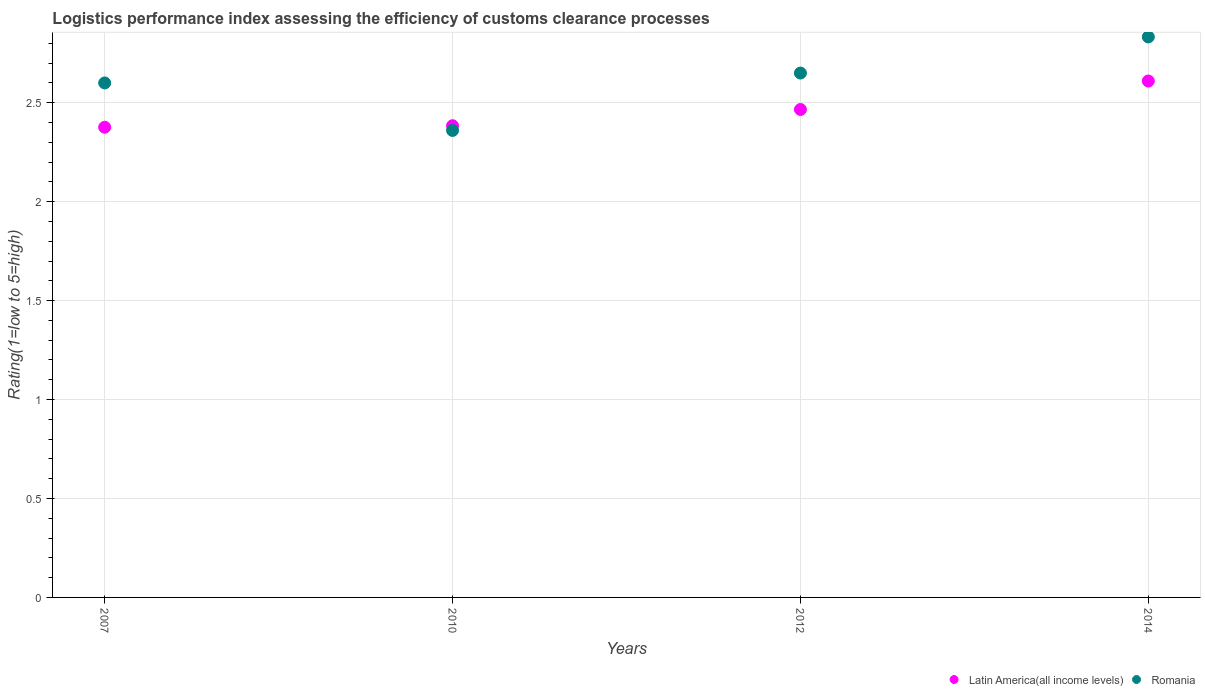How many different coloured dotlines are there?
Provide a succinct answer. 2. Is the number of dotlines equal to the number of legend labels?
Provide a succinct answer. Yes. What is the Logistic performance index in Latin America(all income levels) in 2010?
Offer a very short reply. 2.38. Across all years, what is the maximum Logistic performance index in Romania?
Make the answer very short. 2.83. Across all years, what is the minimum Logistic performance index in Romania?
Ensure brevity in your answer.  2.36. In which year was the Logistic performance index in Romania minimum?
Your answer should be compact. 2010. What is the total Logistic performance index in Latin America(all income levels) in the graph?
Make the answer very short. 9.84. What is the difference between the Logistic performance index in Romania in 2007 and that in 2010?
Keep it short and to the point. 0.24. What is the difference between the Logistic performance index in Romania in 2012 and the Logistic performance index in Latin America(all income levels) in 2010?
Make the answer very short. 0.27. What is the average Logistic performance index in Latin America(all income levels) per year?
Provide a short and direct response. 2.46. In the year 2014, what is the difference between the Logistic performance index in Latin America(all income levels) and Logistic performance index in Romania?
Provide a short and direct response. -0.22. In how many years, is the Logistic performance index in Latin America(all income levels) greater than 0.30000000000000004?
Offer a terse response. 4. What is the ratio of the Logistic performance index in Latin America(all income levels) in 2007 to that in 2010?
Make the answer very short. 1. Is the difference between the Logistic performance index in Latin America(all income levels) in 2007 and 2014 greater than the difference between the Logistic performance index in Romania in 2007 and 2014?
Offer a terse response. No. What is the difference between the highest and the second highest Logistic performance index in Romania?
Your answer should be very brief. 0.18. What is the difference between the highest and the lowest Logistic performance index in Romania?
Ensure brevity in your answer.  0.47. Is the sum of the Logistic performance index in Romania in 2010 and 2014 greater than the maximum Logistic performance index in Latin America(all income levels) across all years?
Keep it short and to the point. Yes. Does the Logistic performance index in Latin America(all income levels) monotonically increase over the years?
Your answer should be compact. Yes. Is the Logistic performance index in Latin America(all income levels) strictly greater than the Logistic performance index in Romania over the years?
Your response must be concise. No. Is the Logistic performance index in Latin America(all income levels) strictly less than the Logistic performance index in Romania over the years?
Give a very brief answer. No. How many dotlines are there?
Provide a short and direct response. 2. How many years are there in the graph?
Keep it short and to the point. 4. Does the graph contain any zero values?
Ensure brevity in your answer.  No. Does the graph contain grids?
Ensure brevity in your answer.  Yes. Where does the legend appear in the graph?
Ensure brevity in your answer.  Bottom right. What is the title of the graph?
Give a very brief answer. Logistics performance index assessing the efficiency of customs clearance processes. What is the label or title of the X-axis?
Your response must be concise. Years. What is the label or title of the Y-axis?
Your answer should be compact. Rating(1=low to 5=high). What is the Rating(1=low to 5=high) in Latin America(all income levels) in 2007?
Offer a terse response. 2.38. What is the Rating(1=low to 5=high) of Romania in 2007?
Your response must be concise. 2.6. What is the Rating(1=low to 5=high) in Latin America(all income levels) in 2010?
Your answer should be compact. 2.38. What is the Rating(1=low to 5=high) of Romania in 2010?
Keep it short and to the point. 2.36. What is the Rating(1=low to 5=high) in Latin America(all income levels) in 2012?
Make the answer very short. 2.47. What is the Rating(1=low to 5=high) in Romania in 2012?
Ensure brevity in your answer.  2.65. What is the Rating(1=low to 5=high) in Latin America(all income levels) in 2014?
Offer a terse response. 2.61. What is the Rating(1=low to 5=high) in Romania in 2014?
Your response must be concise. 2.83. Across all years, what is the maximum Rating(1=low to 5=high) of Latin America(all income levels)?
Ensure brevity in your answer.  2.61. Across all years, what is the maximum Rating(1=low to 5=high) of Romania?
Provide a succinct answer. 2.83. Across all years, what is the minimum Rating(1=low to 5=high) in Latin America(all income levels)?
Give a very brief answer. 2.38. Across all years, what is the minimum Rating(1=low to 5=high) in Romania?
Provide a short and direct response. 2.36. What is the total Rating(1=low to 5=high) in Latin America(all income levels) in the graph?
Make the answer very short. 9.84. What is the total Rating(1=low to 5=high) in Romania in the graph?
Give a very brief answer. 10.44. What is the difference between the Rating(1=low to 5=high) of Latin America(all income levels) in 2007 and that in 2010?
Your answer should be compact. -0.01. What is the difference between the Rating(1=low to 5=high) in Romania in 2007 and that in 2010?
Provide a succinct answer. 0.24. What is the difference between the Rating(1=low to 5=high) of Latin America(all income levels) in 2007 and that in 2012?
Make the answer very short. -0.09. What is the difference between the Rating(1=low to 5=high) in Romania in 2007 and that in 2012?
Offer a very short reply. -0.05. What is the difference between the Rating(1=low to 5=high) of Latin America(all income levels) in 2007 and that in 2014?
Your answer should be compact. -0.23. What is the difference between the Rating(1=low to 5=high) in Romania in 2007 and that in 2014?
Your answer should be compact. -0.23. What is the difference between the Rating(1=low to 5=high) in Latin America(all income levels) in 2010 and that in 2012?
Offer a very short reply. -0.08. What is the difference between the Rating(1=low to 5=high) in Romania in 2010 and that in 2012?
Offer a terse response. -0.29. What is the difference between the Rating(1=low to 5=high) of Latin America(all income levels) in 2010 and that in 2014?
Provide a short and direct response. -0.23. What is the difference between the Rating(1=low to 5=high) of Romania in 2010 and that in 2014?
Make the answer very short. -0.47. What is the difference between the Rating(1=low to 5=high) in Latin America(all income levels) in 2012 and that in 2014?
Provide a short and direct response. -0.14. What is the difference between the Rating(1=low to 5=high) in Romania in 2012 and that in 2014?
Give a very brief answer. -0.18. What is the difference between the Rating(1=low to 5=high) of Latin America(all income levels) in 2007 and the Rating(1=low to 5=high) of Romania in 2010?
Give a very brief answer. 0.02. What is the difference between the Rating(1=low to 5=high) in Latin America(all income levels) in 2007 and the Rating(1=low to 5=high) in Romania in 2012?
Your answer should be compact. -0.27. What is the difference between the Rating(1=low to 5=high) in Latin America(all income levels) in 2007 and the Rating(1=low to 5=high) in Romania in 2014?
Offer a very short reply. -0.46. What is the difference between the Rating(1=low to 5=high) of Latin America(all income levels) in 2010 and the Rating(1=low to 5=high) of Romania in 2012?
Your answer should be compact. -0.27. What is the difference between the Rating(1=low to 5=high) of Latin America(all income levels) in 2010 and the Rating(1=low to 5=high) of Romania in 2014?
Keep it short and to the point. -0.45. What is the difference between the Rating(1=low to 5=high) in Latin America(all income levels) in 2012 and the Rating(1=low to 5=high) in Romania in 2014?
Offer a terse response. -0.37. What is the average Rating(1=low to 5=high) of Latin America(all income levels) per year?
Make the answer very short. 2.46. What is the average Rating(1=low to 5=high) in Romania per year?
Offer a terse response. 2.61. In the year 2007, what is the difference between the Rating(1=low to 5=high) of Latin America(all income levels) and Rating(1=low to 5=high) of Romania?
Your answer should be very brief. -0.22. In the year 2010, what is the difference between the Rating(1=low to 5=high) of Latin America(all income levels) and Rating(1=low to 5=high) of Romania?
Offer a terse response. 0.02. In the year 2012, what is the difference between the Rating(1=low to 5=high) in Latin America(all income levels) and Rating(1=low to 5=high) in Romania?
Your answer should be very brief. -0.18. In the year 2014, what is the difference between the Rating(1=low to 5=high) of Latin America(all income levels) and Rating(1=low to 5=high) of Romania?
Keep it short and to the point. -0.22. What is the ratio of the Rating(1=low to 5=high) in Romania in 2007 to that in 2010?
Ensure brevity in your answer.  1.1. What is the ratio of the Rating(1=low to 5=high) of Latin America(all income levels) in 2007 to that in 2012?
Your response must be concise. 0.96. What is the ratio of the Rating(1=low to 5=high) in Romania in 2007 to that in 2012?
Make the answer very short. 0.98. What is the ratio of the Rating(1=low to 5=high) in Latin America(all income levels) in 2007 to that in 2014?
Offer a terse response. 0.91. What is the ratio of the Rating(1=low to 5=high) in Romania in 2007 to that in 2014?
Keep it short and to the point. 0.92. What is the ratio of the Rating(1=low to 5=high) of Latin America(all income levels) in 2010 to that in 2012?
Give a very brief answer. 0.97. What is the ratio of the Rating(1=low to 5=high) in Romania in 2010 to that in 2012?
Your response must be concise. 0.89. What is the ratio of the Rating(1=low to 5=high) of Latin America(all income levels) in 2010 to that in 2014?
Keep it short and to the point. 0.91. What is the ratio of the Rating(1=low to 5=high) in Romania in 2010 to that in 2014?
Your answer should be very brief. 0.83. What is the ratio of the Rating(1=low to 5=high) of Latin America(all income levels) in 2012 to that in 2014?
Give a very brief answer. 0.94. What is the ratio of the Rating(1=low to 5=high) in Romania in 2012 to that in 2014?
Give a very brief answer. 0.94. What is the difference between the highest and the second highest Rating(1=low to 5=high) of Latin America(all income levels)?
Provide a short and direct response. 0.14. What is the difference between the highest and the second highest Rating(1=low to 5=high) of Romania?
Provide a short and direct response. 0.18. What is the difference between the highest and the lowest Rating(1=low to 5=high) of Latin America(all income levels)?
Your answer should be very brief. 0.23. What is the difference between the highest and the lowest Rating(1=low to 5=high) of Romania?
Your answer should be compact. 0.47. 